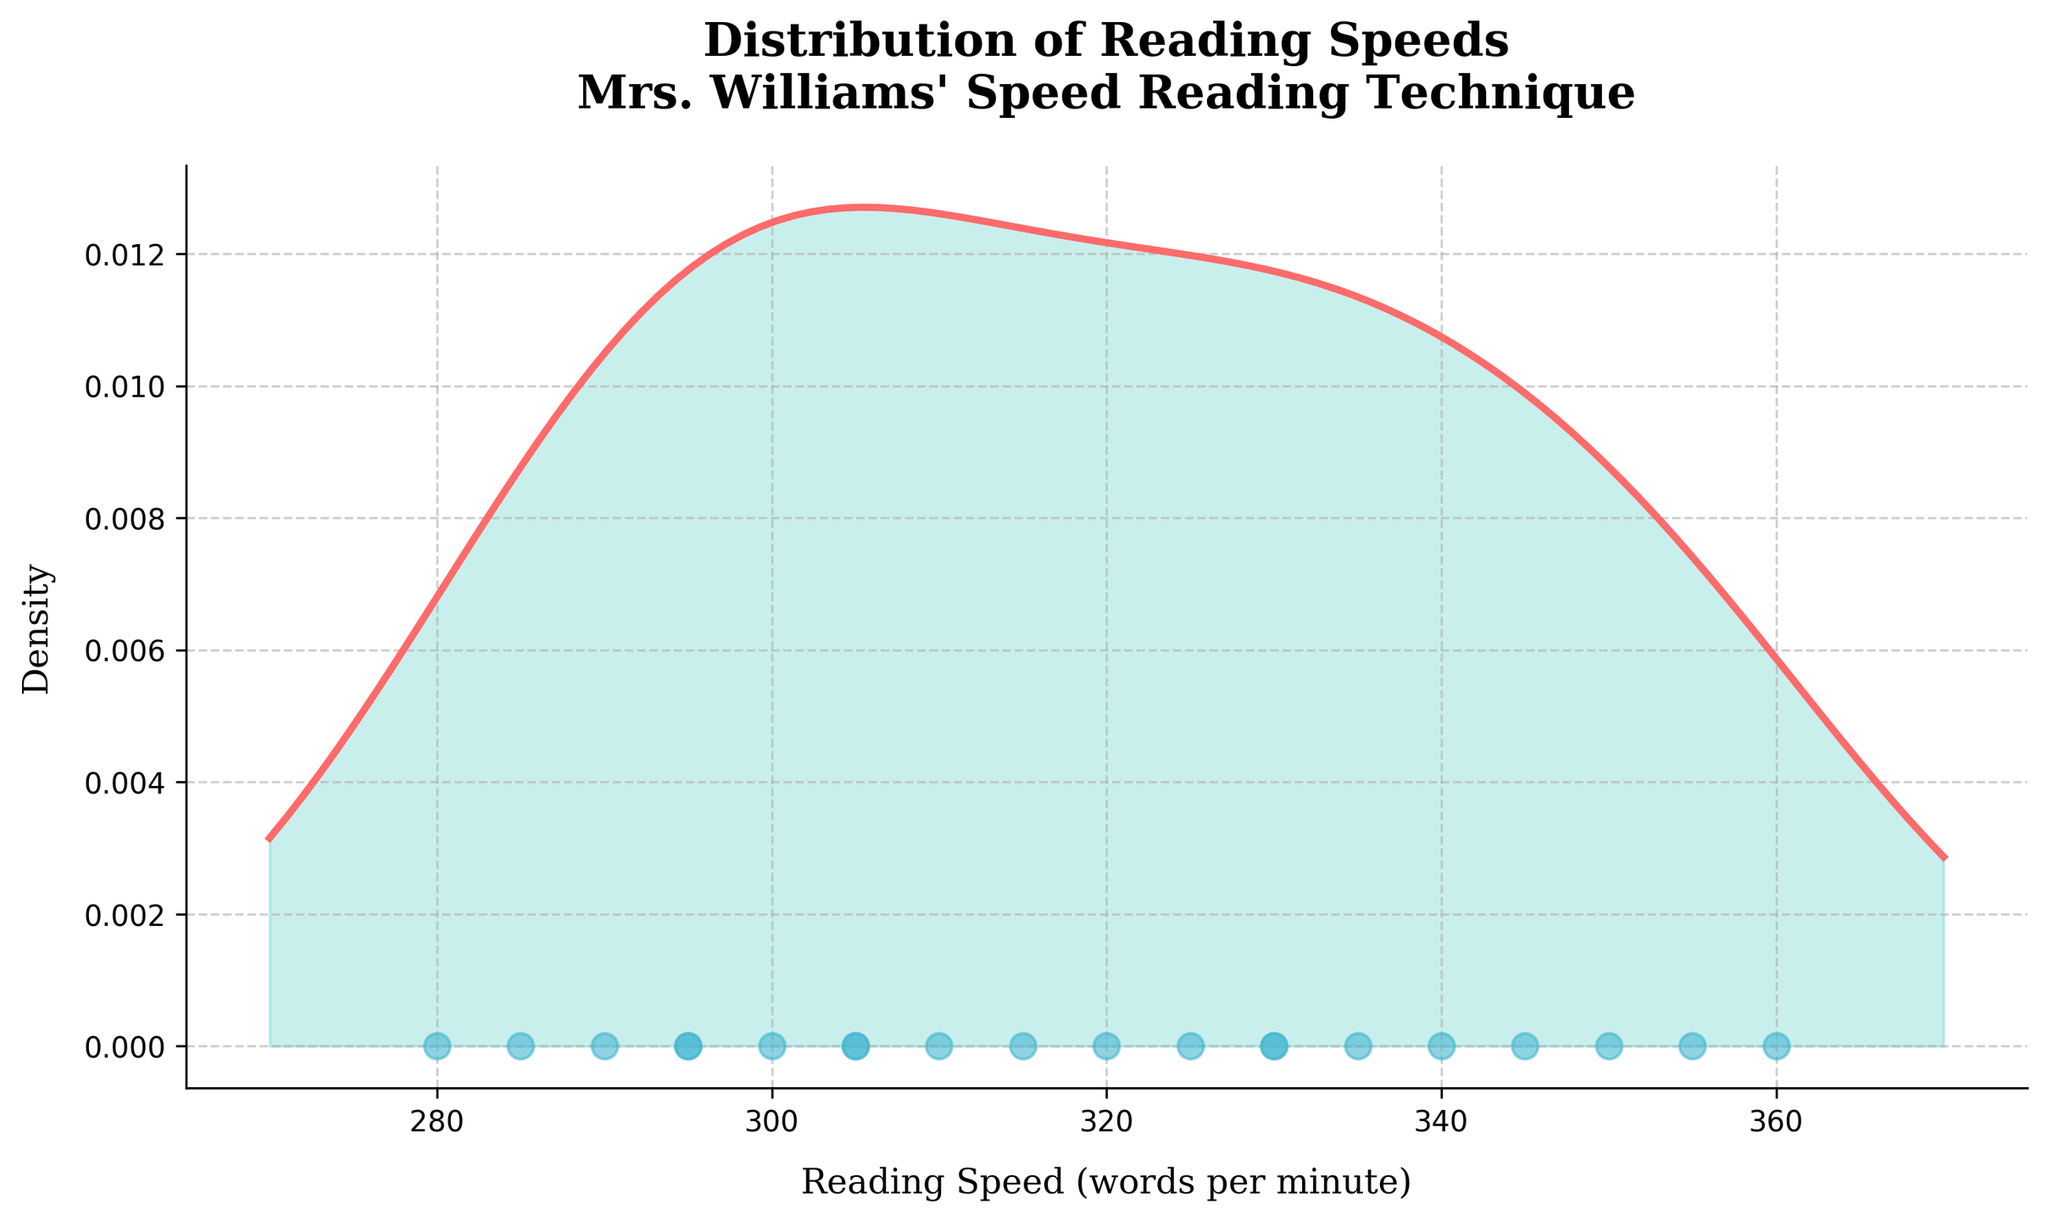What is the title of the density plot? The title of the density plot is usually displayed at the top of the figure. Here, it is designed to display the context of the analysis.
Answer: "Distribution of Reading Speeds\nMrs. Williams' Speed Reading Technique" How many students' reading speeds are represented in the plot? The number of data points in the scatter plot at the bottom of the density plot indicates the number of students whose reading speeds are represented.
Answer: 20 What is the general shape of the density distribution for reading speeds? The shape of the density plot reveals the distribution of reading speeds among students. We look for peaks and the width of the distribution.
Answer: Bell-shaped What is the reading speed range covered in the plot? By examining the x-axis, we see the minimum and maximum reading speeds covered in the plot. The plot usually extends slightly beyond the min and max speeds.
Answer: 270-370 words per minute Which reading speed has the highest density? The peak of the density plot represents the reading speed with the highest density, indicating where most students fall within.
Answer: Approximately 320-330 words per minute Does the distribution show any skewness? Skewness is indicated by the asymmetry in the density plot. If one tail is longer than the other, the distribution is skewed.
Answer: No, it appears fairly symmetrical How many students have a reading speed of exactly 305 words per minute? Points directly on the x-axis aligned with 305 words per minute and represented by scatter markers indicate the quantity.
Answer: 2 What is the approximate density of students with a reading speed around 360 words per minute? Around 360 on the x-axis, where the density plot line stands, observe the y-value to approximate the density.
Answer: Low density Is there a significant difference in density between 280 and 290 words per minute? Compare the heights of the density plot line at 280 and 290. The difference indicates whether the reading behaviours cluster significantly more around one of these speeds.
Answer: Density is higher around 290 Which reading speed has the lowest density? The lowest density is where the density plot line is at its minimum. Identify the speed with minimal y-value on the curve.
Answer: Approximately 360 words per minute 